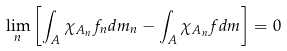<formula> <loc_0><loc_0><loc_500><loc_500>\lim _ { n } \left [ \int _ { A } \chi _ { A _ { n } } f _ { n } d m _ { n } - \int _ { A } \chi _ { A _ { n } } f d m \right ] = 0</formula> 